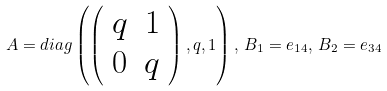<formula> <loc_0><loc_0><loc_500><loc_500>A = d i a g \left ( \left ( \begin{array} { c c } q & 1 \\ 0 & q \\ \end{array} \right ) , q , 1 \right ) , \, B _ { 1 } = e _ { 1 4 } , \, B _ { 2 } = e _ { 3 4 }</formula> 